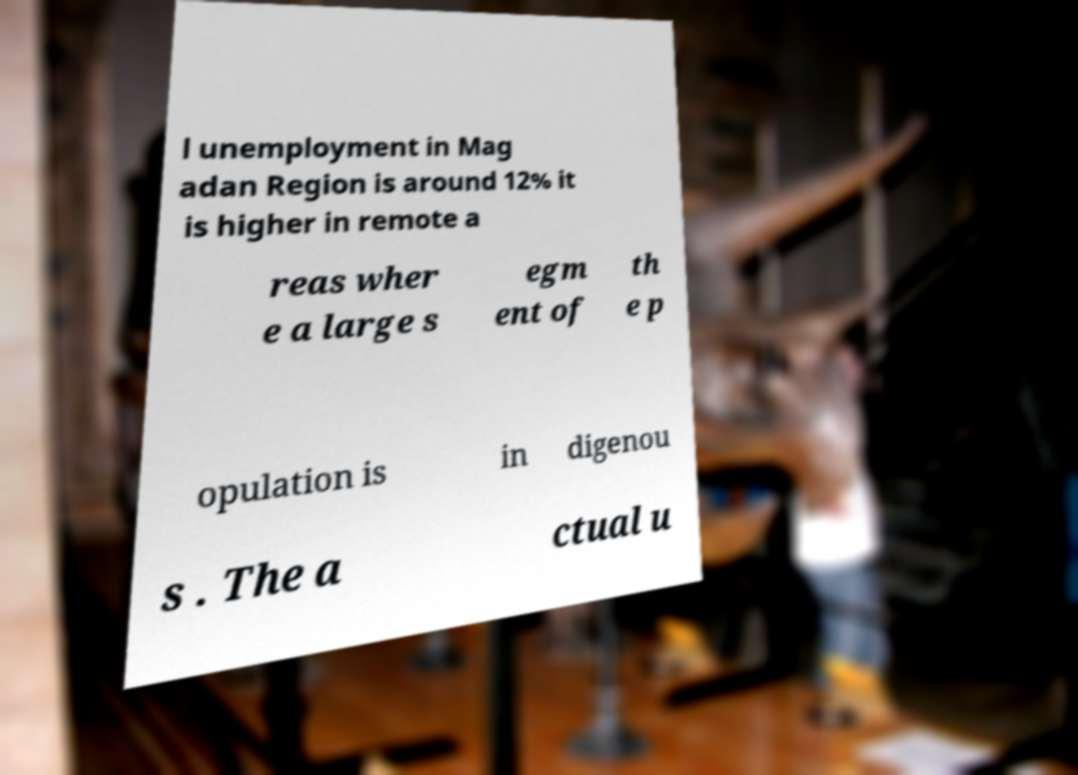Please read and relay the text visible in this image. What does it say? l unemployment in Mag adan Region is around 12% it is higher in remote a reas wher e a large s egm ent of th e p opulation is in digenou s . The a ctual u 